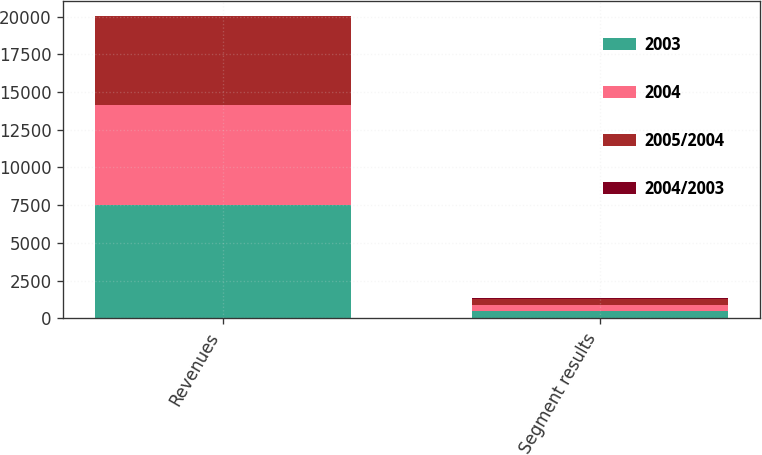Convert chart to OTSL. <chart><loc_0><loc_0><loc_500><loc_500><stacked_bar_chart><ecel><fcel>Revenues<fcel>Segment results<nl><fcel>2003<fcel>7535<fcel>474<nl><fcel>2004<fcel>6611<fcel>426<nl><fcel>2005/2004<fcel>5876<fcel>407<nl><fcel>2004/2003<fcel>14<fcel>11<nl></chart> 